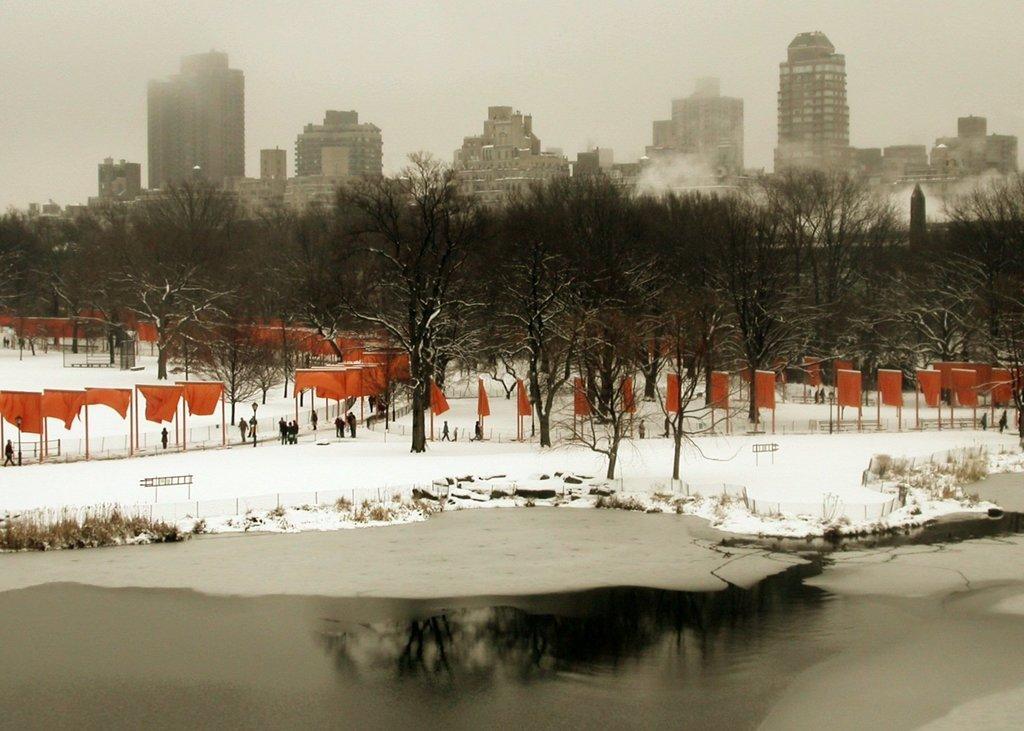In one or two sentences, can you explain what this image depicts? In this picture we can see some water and this is snow. Here we can see some persons are standing and these are the red colored flags. And these are the trees. And on the background there are many buildings. And this is the sky. 